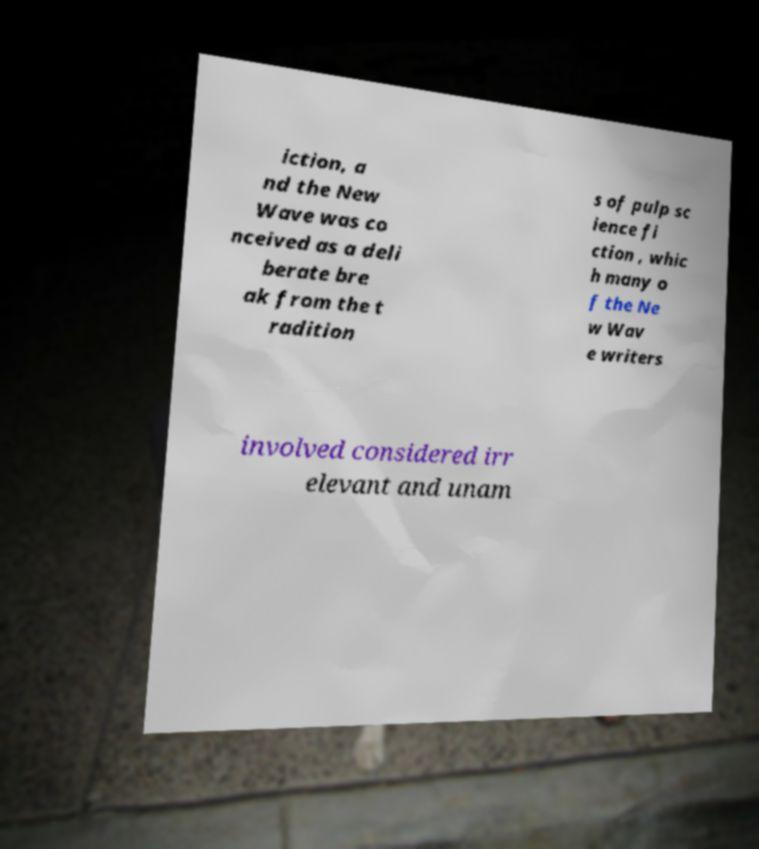I need the written content from this picture converted into text. Can you do that? iction, a nd the New Wave was co nceived as a deli berate bre ak from the t radition s of pulp sc ience fi ction , whic h many o f the Ne w Wav e writers involved considered irr elevant and unam 